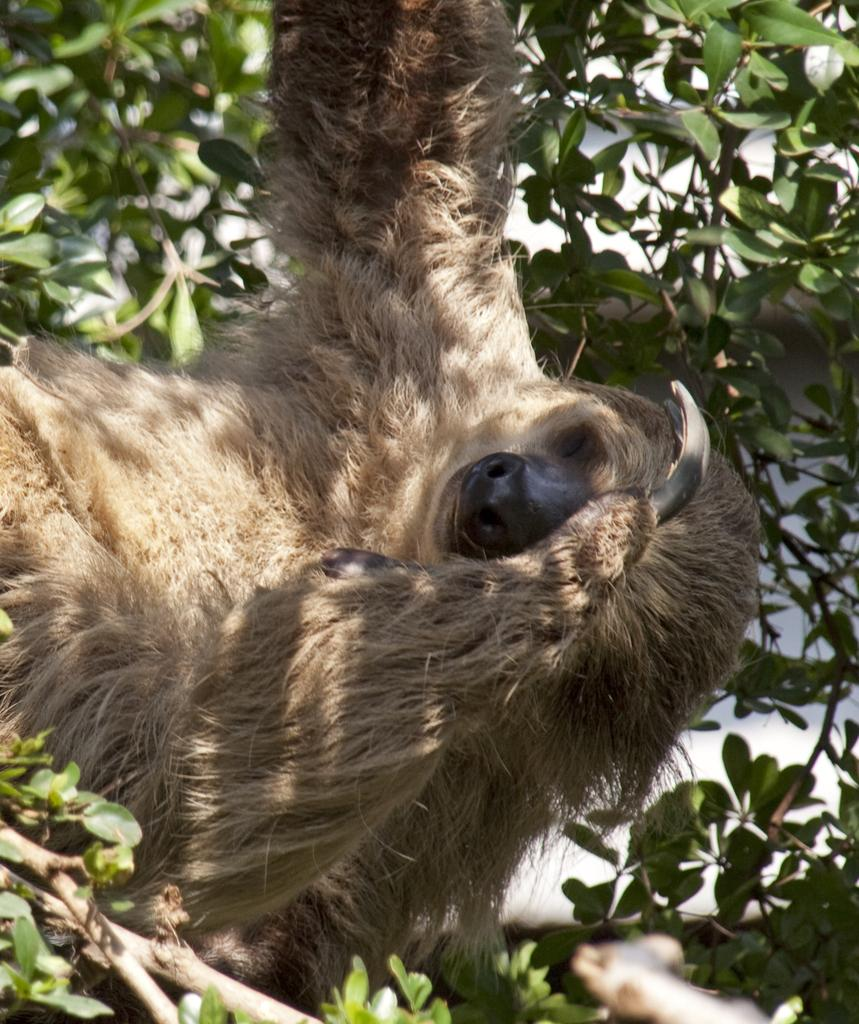What type of animal can be seen in the image? There is an animal in the image, but its specific type cannot be determined from the provided facts. Where is the animal located in the image? The animal is sitting on a tree in the image. What is the color of the tree? The tree is in light brown color. Is there a party happening in the image? There is no mention of a party in the image. --- Facts: 1. There is a person in the image. 2. The person is wearing a hat. 3. The person is holding a book. 4. The book has a red cover. Absurd Topics: bicycle, umbrella Conversation: What is the main subject in the image? The main subject in the image is a person. What is the person wearing in the image? The person is wearing a hat. What is the person holding in the image? The person is holding a book. What is the color of the book's cover? The book has a red cover. Reasoning: Let's think step by step in order to produce the conversation. We start by identifying the main subject of the image, which is a person. Next, we describe specific features of the person, such as the hat. Then, we observe the actions of the person in the image, noting that they are holding a book. Finally, we describe the color of the book's cover, which is red. Absurd Question/Answer: How many bicycles can be seen in the image? There are no bicycles present in the image. --- Facts: 1. There is a car in the image. 2. The car is red in color. 3. The car has four wheels. 4. The car is parked on the street. Absurd Topics: piano Conversation: What type of vehicle can be seen in the image? The type of vehicle that can be seen in the image is a car. What is the color of the car in the image? The color of the car in the image is red. How many wheels does the car have in the image? The car has four wheels in the image. Where is the car located in the image? The car is parked on the street in the image. Reasoning: Let's think step by step in order to produce the conversation. We start by identifying the main subject of the image, which is a car. Next, we describe specific features of the car, such as the color and the number of wheels. Then, we observe the location of the car in the image, noting that it is parked on the street. Absurd Question/Answer: Can you hear the piano playing in the background of the image? There is no mention of a piano in the image, so it cannot be heard playing in the background of the image. --- Facts: 1. 